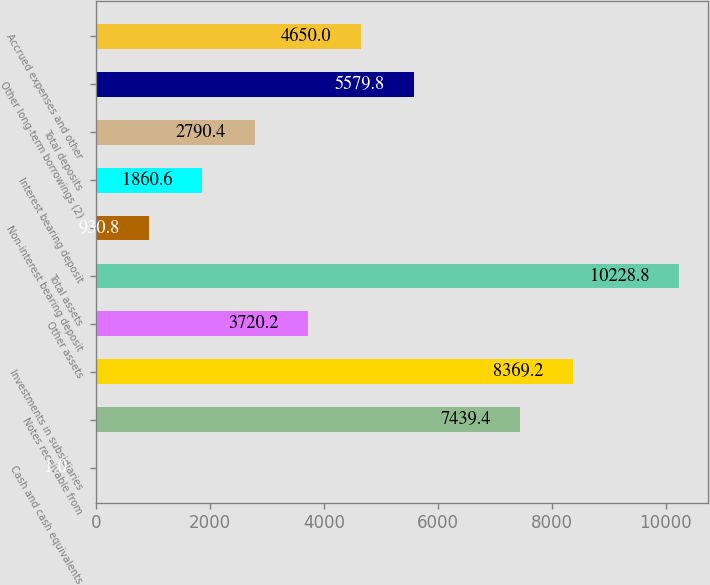Convert chart. <chart><loc_0><loc_0><loc_500><loc_500><bar_chart><fcel>Cash and cash equivalents<fcel>Notes receivable from<fcel>Investments in subsidiaries<fcel>Other assets<fcel>Total assets<fcel>Non-interest bearing deposit<fcel>Interest bearing deposit<fcel>Total deposits<fcel>Other long-term borrowings (2)<fcel>Accrued expenses and other<nl><fcel>1<fcel>7439.4<fcel>8369.2<fcel>3720.2<fcel>10228.8<fcel>930.8<fcel>1860.6<fcel>2790.4<fcel>5579.8<fcel>4650<nl></chart> 